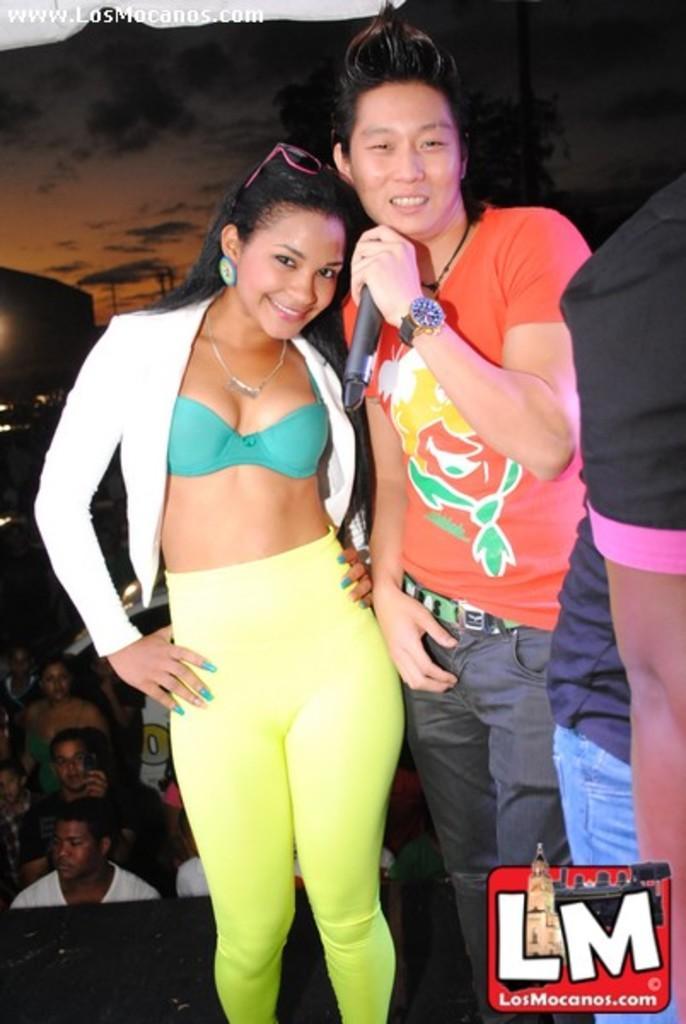Describe this image in one or two sentences. This picture describes about group of people, in the middle of the image we can see a man and woman, she is smiling, and he is holding a microphone. 